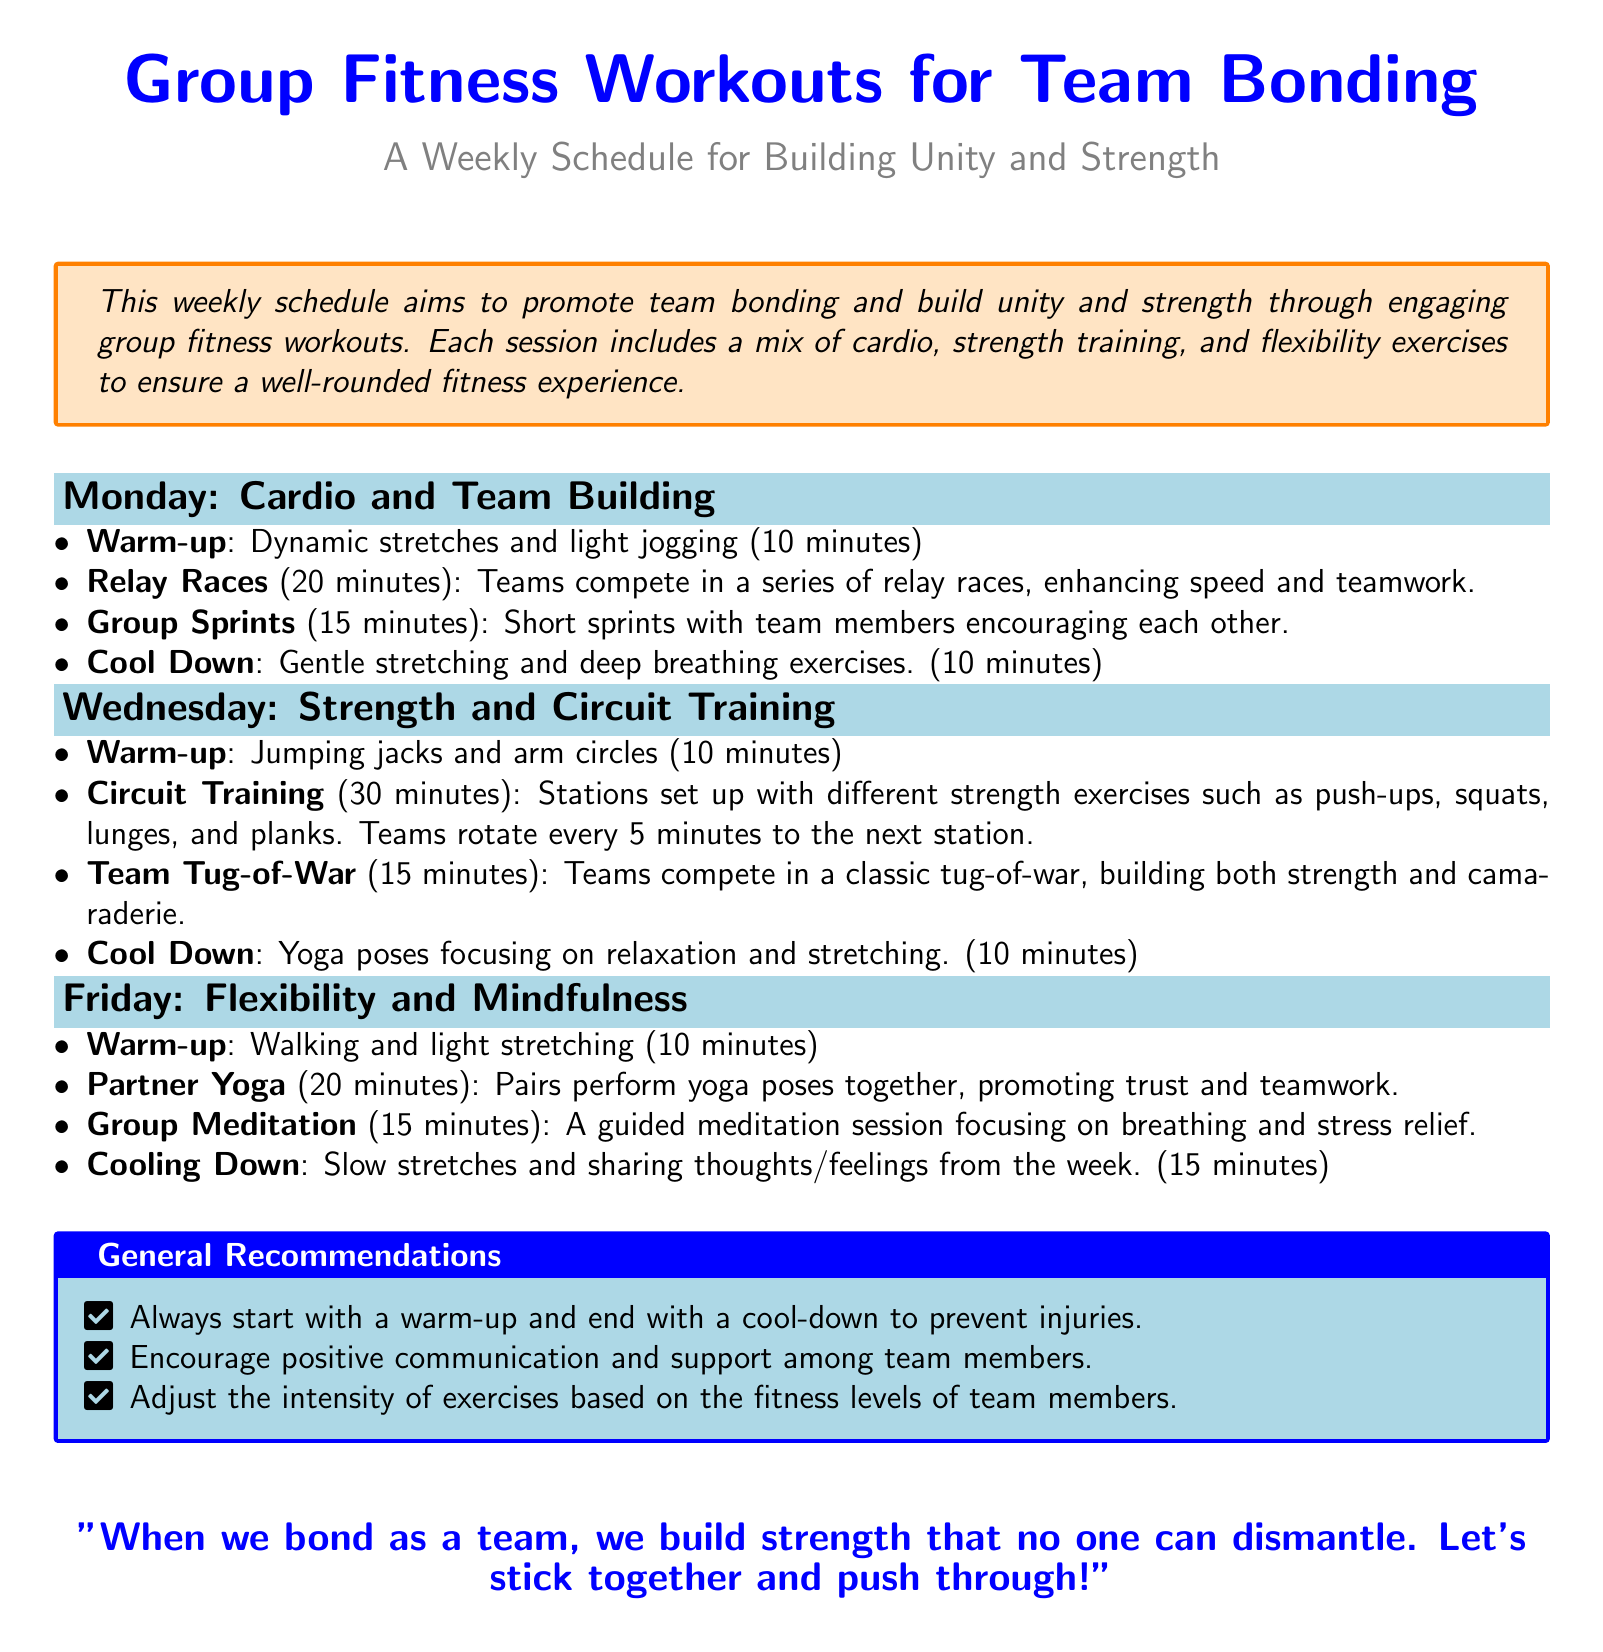What is the focus of the weekly schedule? The document outlines a weekly schedule aimed at promoting team bonding and building unity and strength through group fitness workouts.
Answer: Team bonding and unity How many minutes are allocated for Relay Races? The time specified for Relay Races in the document is 20 minutes.
Answer: 20 minutes What exercise is used to enhance flexibility and mindfulness? The document mentions Partner Yoga as an exercise aimed at enhancing flexibility and mindfulness.
Answer: Partner Yoga On which day is Strength and Circuit Training scheduled? The document clearly indicates that Strength and Circuit Training takes place on Wednesday.
Answer: Wednesday What is the recommended warm-up for Friday's session? The warm-up for Friday's session includes walking and light stretching, as detailed in the document.
Answer: Walking and light stretching What key aspect is emphasized in the general recommendations? The recommendations emphasize the importance of starting with a warm-up and ending with a cool-down.
Answer: Warm-up and cool-down How long is the cooling down period on Friday? The document specifies that the cooling down period on Friday is 15 minutes long.
Answer: 15 minutes What type of training is suggested for Monday’s workout? The training session suggested for Monday focuses on cardio and team building.
Answer: Cardio and team building Which activity promotes trust between participants? The document states that Partner Yoga promotes trust and teamwork between participants.
Answer: Partner Yoga 